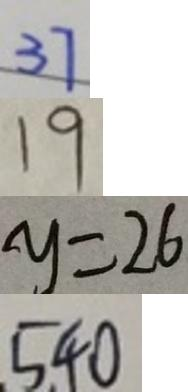Convert formula to latex. <formula><loc_0><loc_0><loc_500><loc_500>3 7 
 1 9 
 y = 2 6 
 5 4 0</formula> 